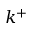Convert formula to latex. <formula><loc_0><loc_0><loc_500><loc_500>k ^ { + }</formula> 